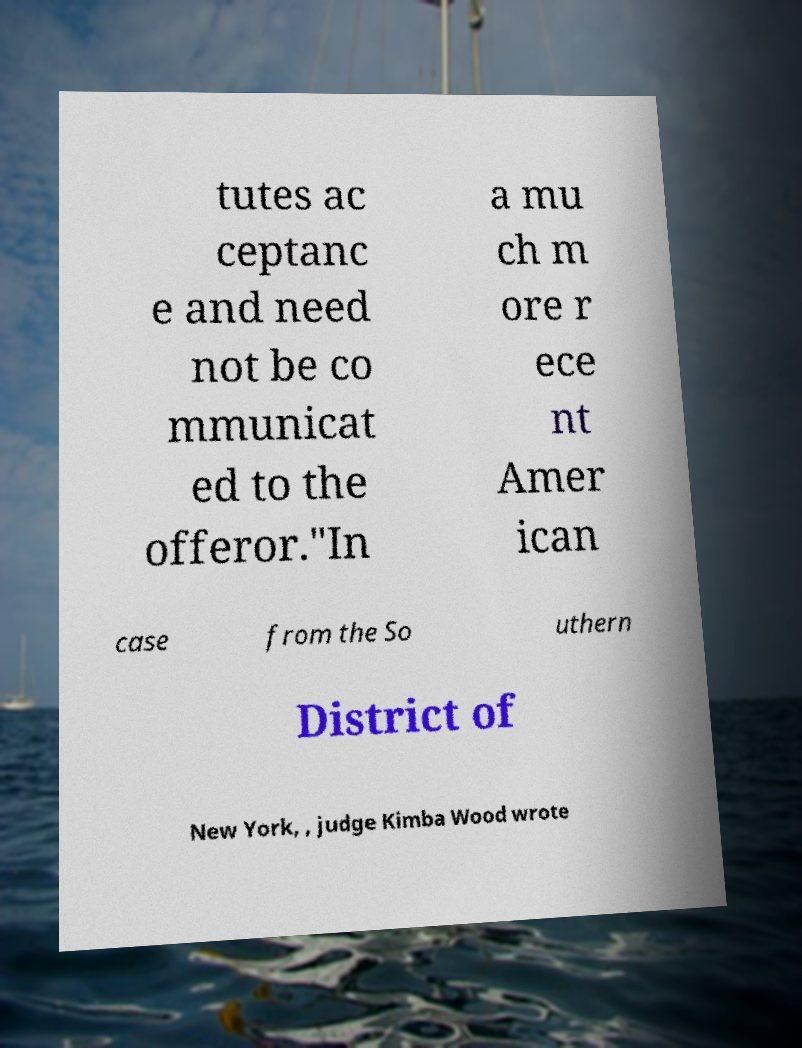Could you extract and type out the text from this image? tutes ac ceptanc e and need not be co mmunicat ed to the offeror."In a mu ch m ore r ece nt Amer ican case from the So uthern District of New York, , judge Kimba Wood wrote 